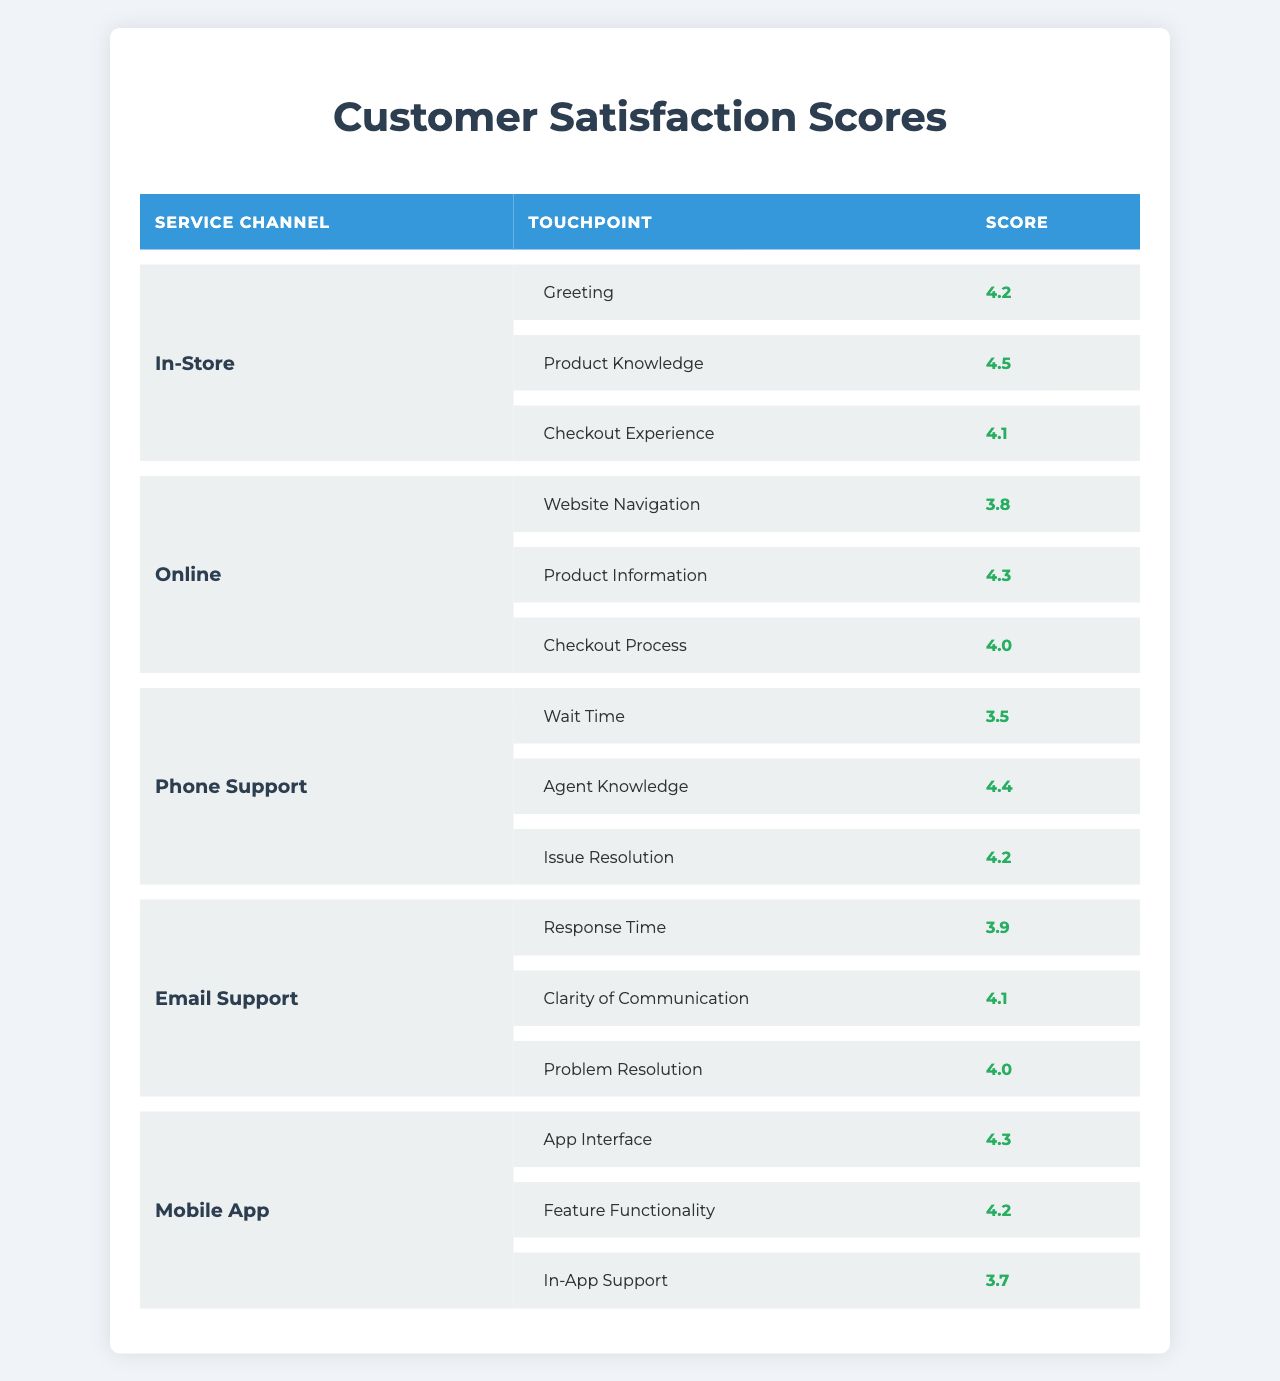What is the highest satisfaction score in the In-Store channel? In the In-Store channel, the touchpoints and their scores are: Greeting (4.2), Product Knowledge (4.5), and Checkout Experience (4.1). The highest score among these is 4.5 for Product Knowledge.
Answer: 4.5 Which service channel has the lowest score for a touchpoint? In the table, the Phone Support channel has the lowest score for the Wait Time touchpoint, which is 3.5.
Answer: 3.5 What is the average satisfaction score for the Online channel? The touchpoints in the Online channel are: Website Navigation (3.8), Product Information (4.3), and Checkout Process (4.0). To find the average, add the scores: 3.8 + 4.3 + 4.0 = 12.1, then divide by the number of touchpoints (3): 12.1 / 3 = 4.033.
Answer: 4.03 Is the average score for Email Support higher than that of Phone Support? The Email Support scores are Response Time (3.9), Clarity of Communication (4.1), and Problem Resolution (4.0), which sum to 12.0 giving an average of 4.0. The Phone Support scores are Wait Time (3.5), Agent Knowledge (4.4), and Issue Resolution (4.2), which sum to 12.1 giving an average of 4.033. Since 4.0 is not higher than 4.033, the answer is no.
Answer: No Which touchpoint in the Mobile App channel has the lowest satisfaction score and what is that score? The Mobile App channel scores are: App Interface (4.3), Feature Functionality (4.2), and In-App Support (3.7). The lowest score is for In-App Support, which is 3.7.
Answer: In-App Support, 3.7 Which service channel has the best average score overall? The average scores for each channel are as follows: In-Store (4.3), Online (4.03), Phone Support (4.033), Email Support (4.0), and Mobile App (4.07). The highest average score is for In-Store, which is 4.3.
Answer: In-Store How many touchpoints in total are scored for all service channels combined? In the data, the total number of touchpoints across all service channels is calculated as follows: In-Store (3), Online (3), Phone Support (3), Email Support (3), and Mobile App (3), resulting in a total of 15 touchpoints.
Answer: 15 Which touchpoint has a score of 3.9 regardless of the service channel? In the table, the only touchpoint that has a score of 3.9 is the Response Time under the Email Support service channel.
Answer: Response Time (Email Support) Is there a touchpoint with a score of 4.4, and if so, which service channel is it associated with? Yes, the touchpoint with a score of 4.4 is Agent Knowledge, and it is associated with the Phone Support service channel.
Answer: Agent Knowledge, Phone Support If we only consider the In-Store and Online channels, which channel has a higher total score? The total score for In-Store is 4.2 + 4.5 + 4.1 = 12.8, while the total score for Online is 3.8 + 4.3 + 4.0 = 12.1. Since 12.8 is greater than 12.1, the In-Store channel has a higher total score.
Answer: In-Store Which service channel's touchpoints include both "Agent Knowledge" and "Feature Functionality"? The touchpoint "Agent Knowledge" is in Phone Support and "Feature Functionality" is in Mobile App; hence, no single service channel includes both touchpoints.
Answer: None 